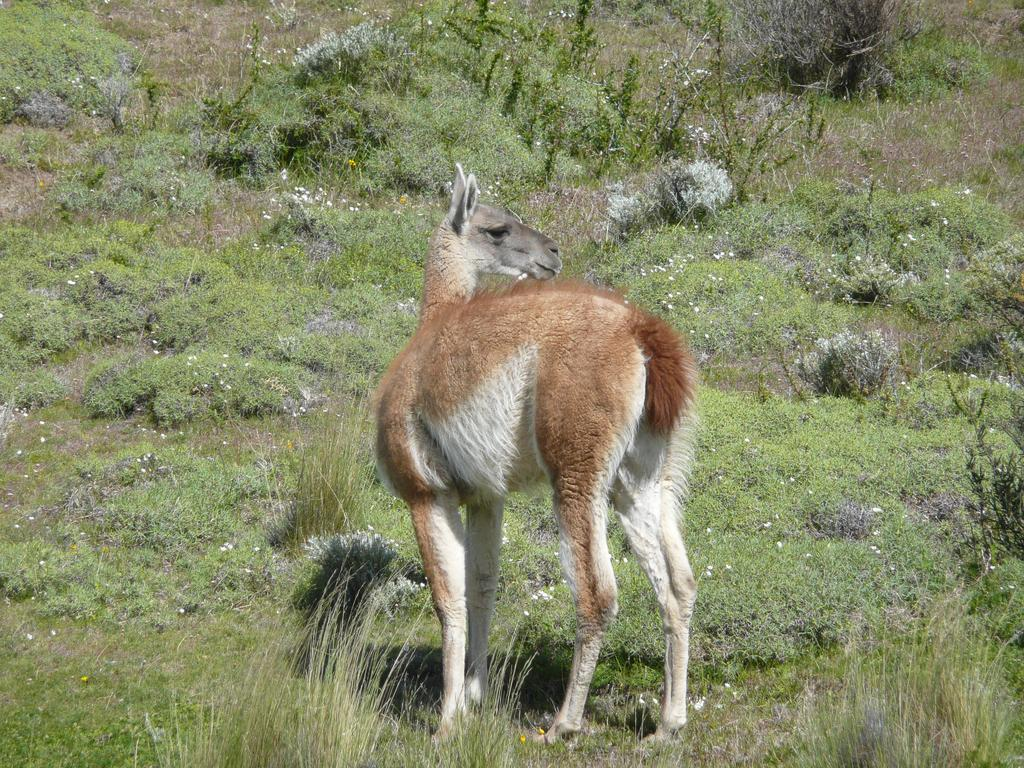What type of vegetation can be seen in the image? There is grass and plants in the image. What else is present in the image besides vegetation? There is an animal in the image. Reasoning: Let's think step by step by step in order to produce the conversation. We start by identifying the main subjects in the image, which are the grass and plants. Then, we expand the conversation to include the animal that is also present in the image. Each question is designed to elicit a specific detail about the image that is known from the provided facts. Absurd Question/Answer: What type of twig is the animal using to carry the yoke in the image? There is no twig or yoke present in the image; it only features grass, plants, and an animal. What type of curve can be seen in the image? There is no curve present in the image; it only features grass, plants, and an animal. 